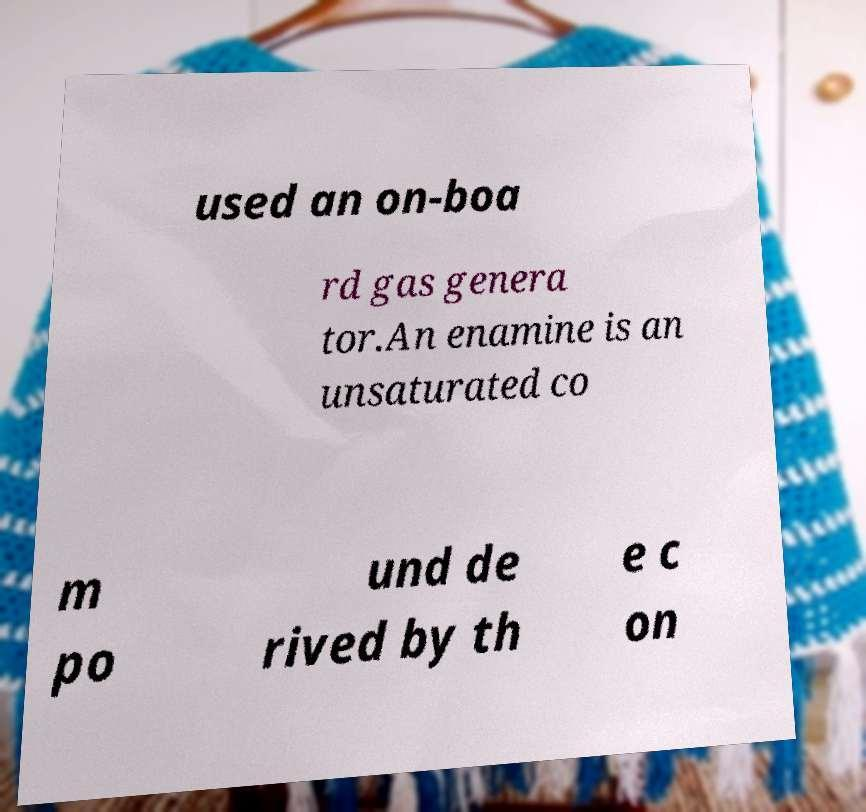There's text embedded in this image that I need extracted. Can you transcribe it verbatim? used an on-boa rd gas genera tor.An enamine is an unsaturated co m po und de rived by th e c on 